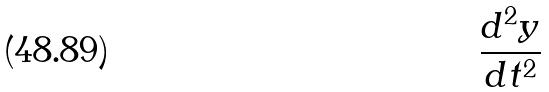Convert formula to latex. <formula><loc_0><loc_0><loc_500><loc_500>\frac { d ^ { 2 } y } { d t ^ { 2 } }</formula> 